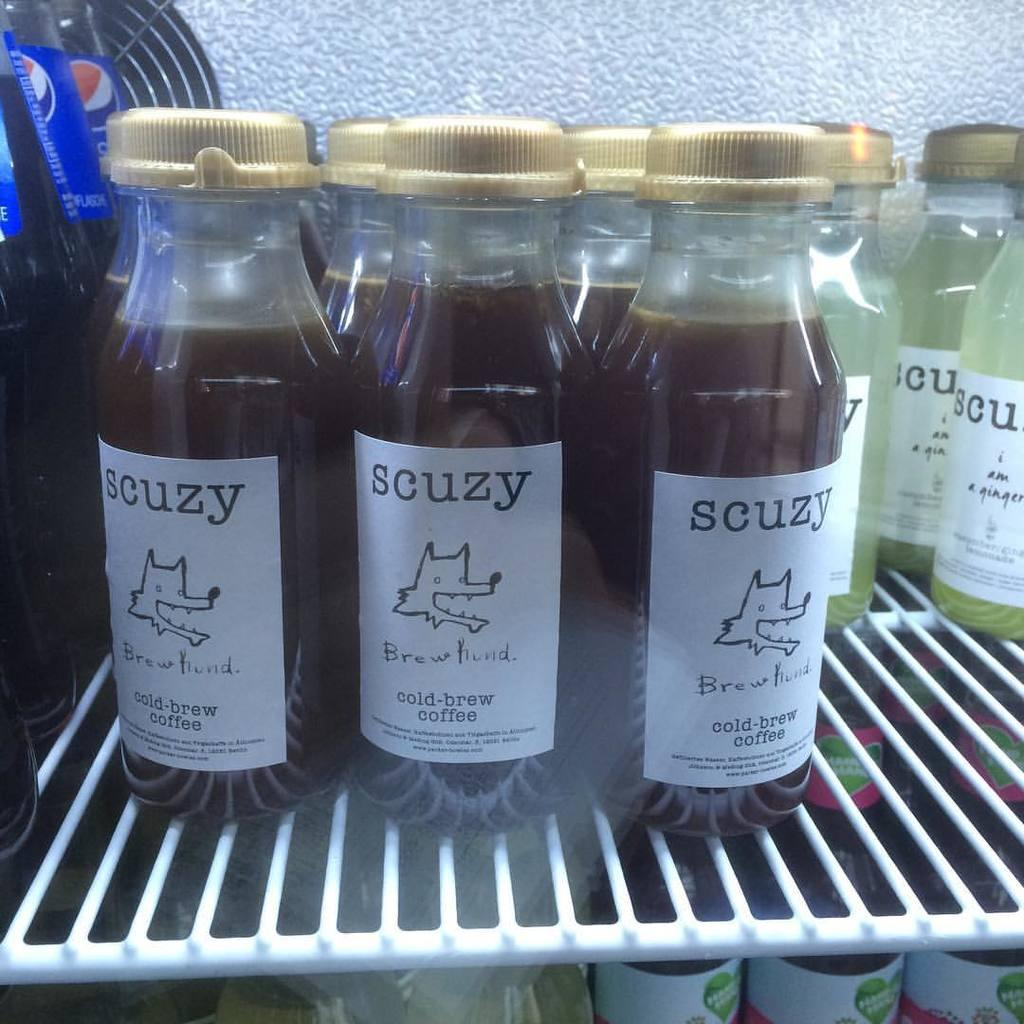What is the main subject of the image? The main subject of the image is many bottles. What is the state of the bottles in the image? The bottles are in a freeze. What type of force is being applied to the wrist in the image? There is no wrist or force present in the image; it only features many bottles in a freeze. 